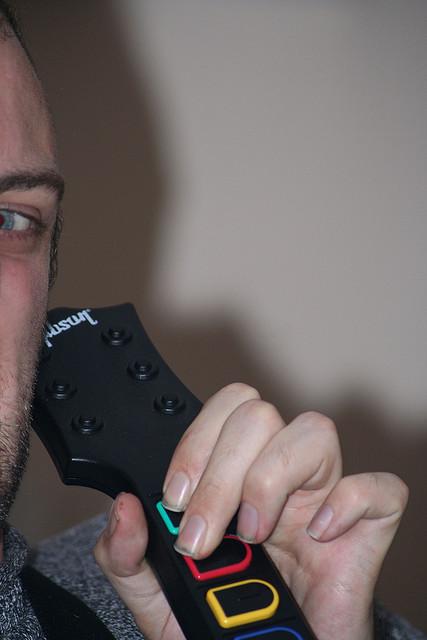What color is the wall?
Be succinct. Beige. What are the different colors for?
Be succinct. Different buttons. What device is the man holding?
Answer briefly. Guitar. What is the person holding?
Concise answer only. Guitar. How many fingers are touching the device?
Answer briefly. 4. What is the color of the remote?
Short answer required. Black. Which finger is being used to press buttons?
Give a very brief answer. Index. Is he holding a cell phone?
Quick response, please. No. 